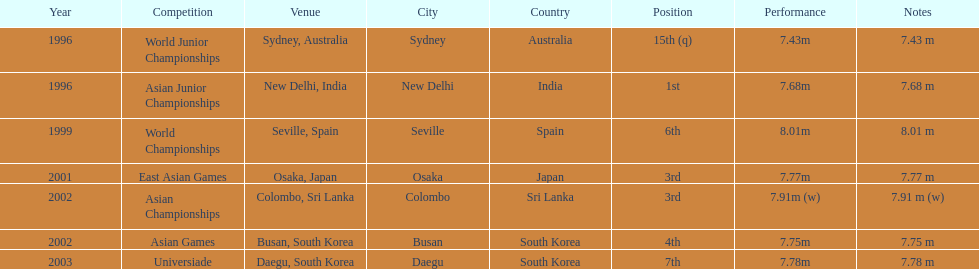What is the difference between the number of times the position of third was achieved and the number of times the position of first was achieved? 1. 